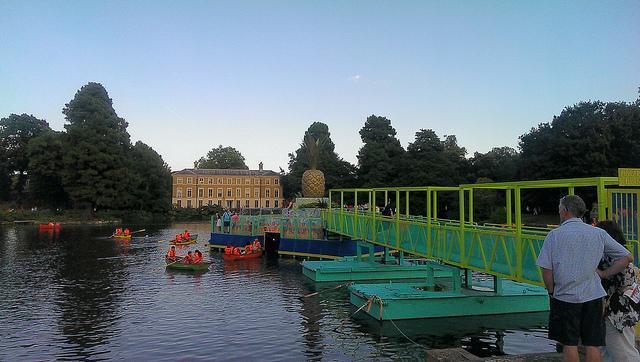How many boats are there?
Give a very brief answer. 5. How many people are visible?
Give a very brief answer. 2. How many cars are to the left of the bus?
Give a very brief answer. 0. 